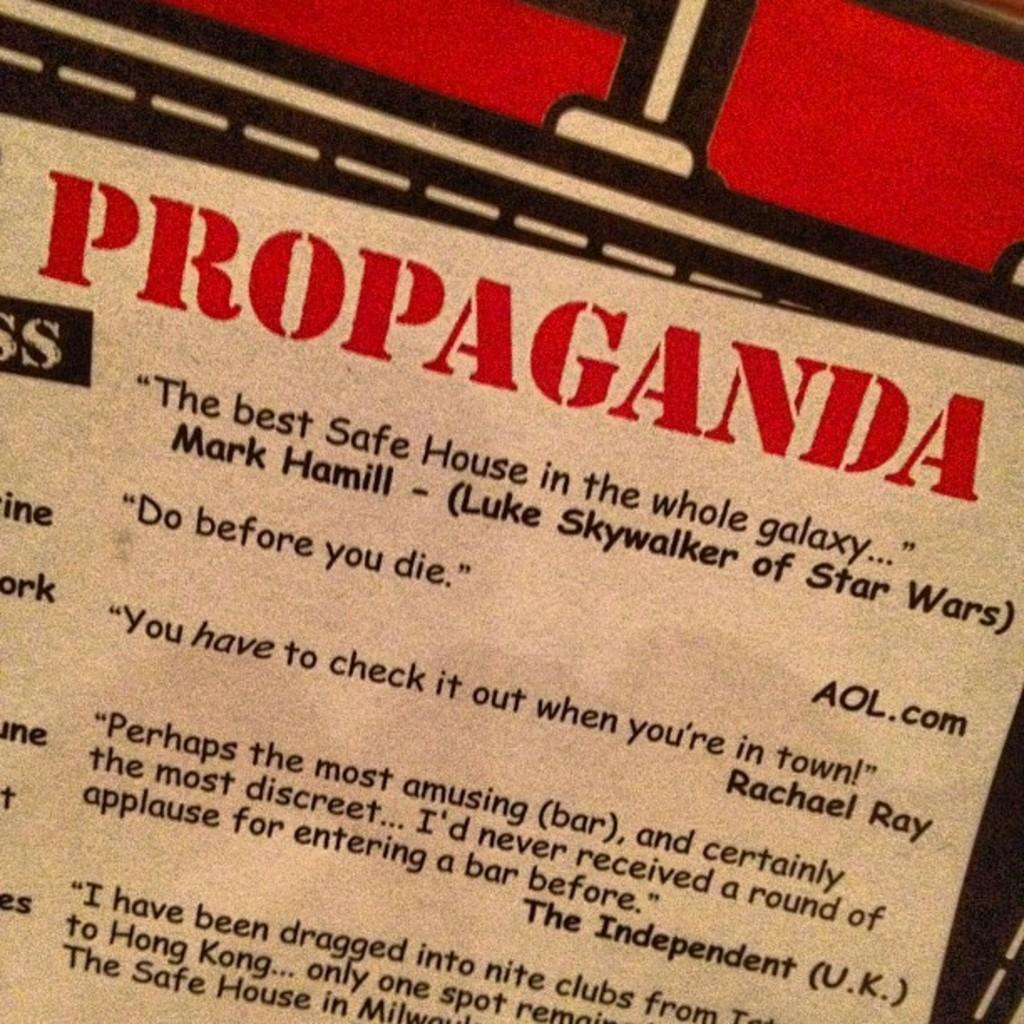<image>
Render a clear and concise summary of the photo. A sign that says "Propaganda" on it and a bunch of quotes. 